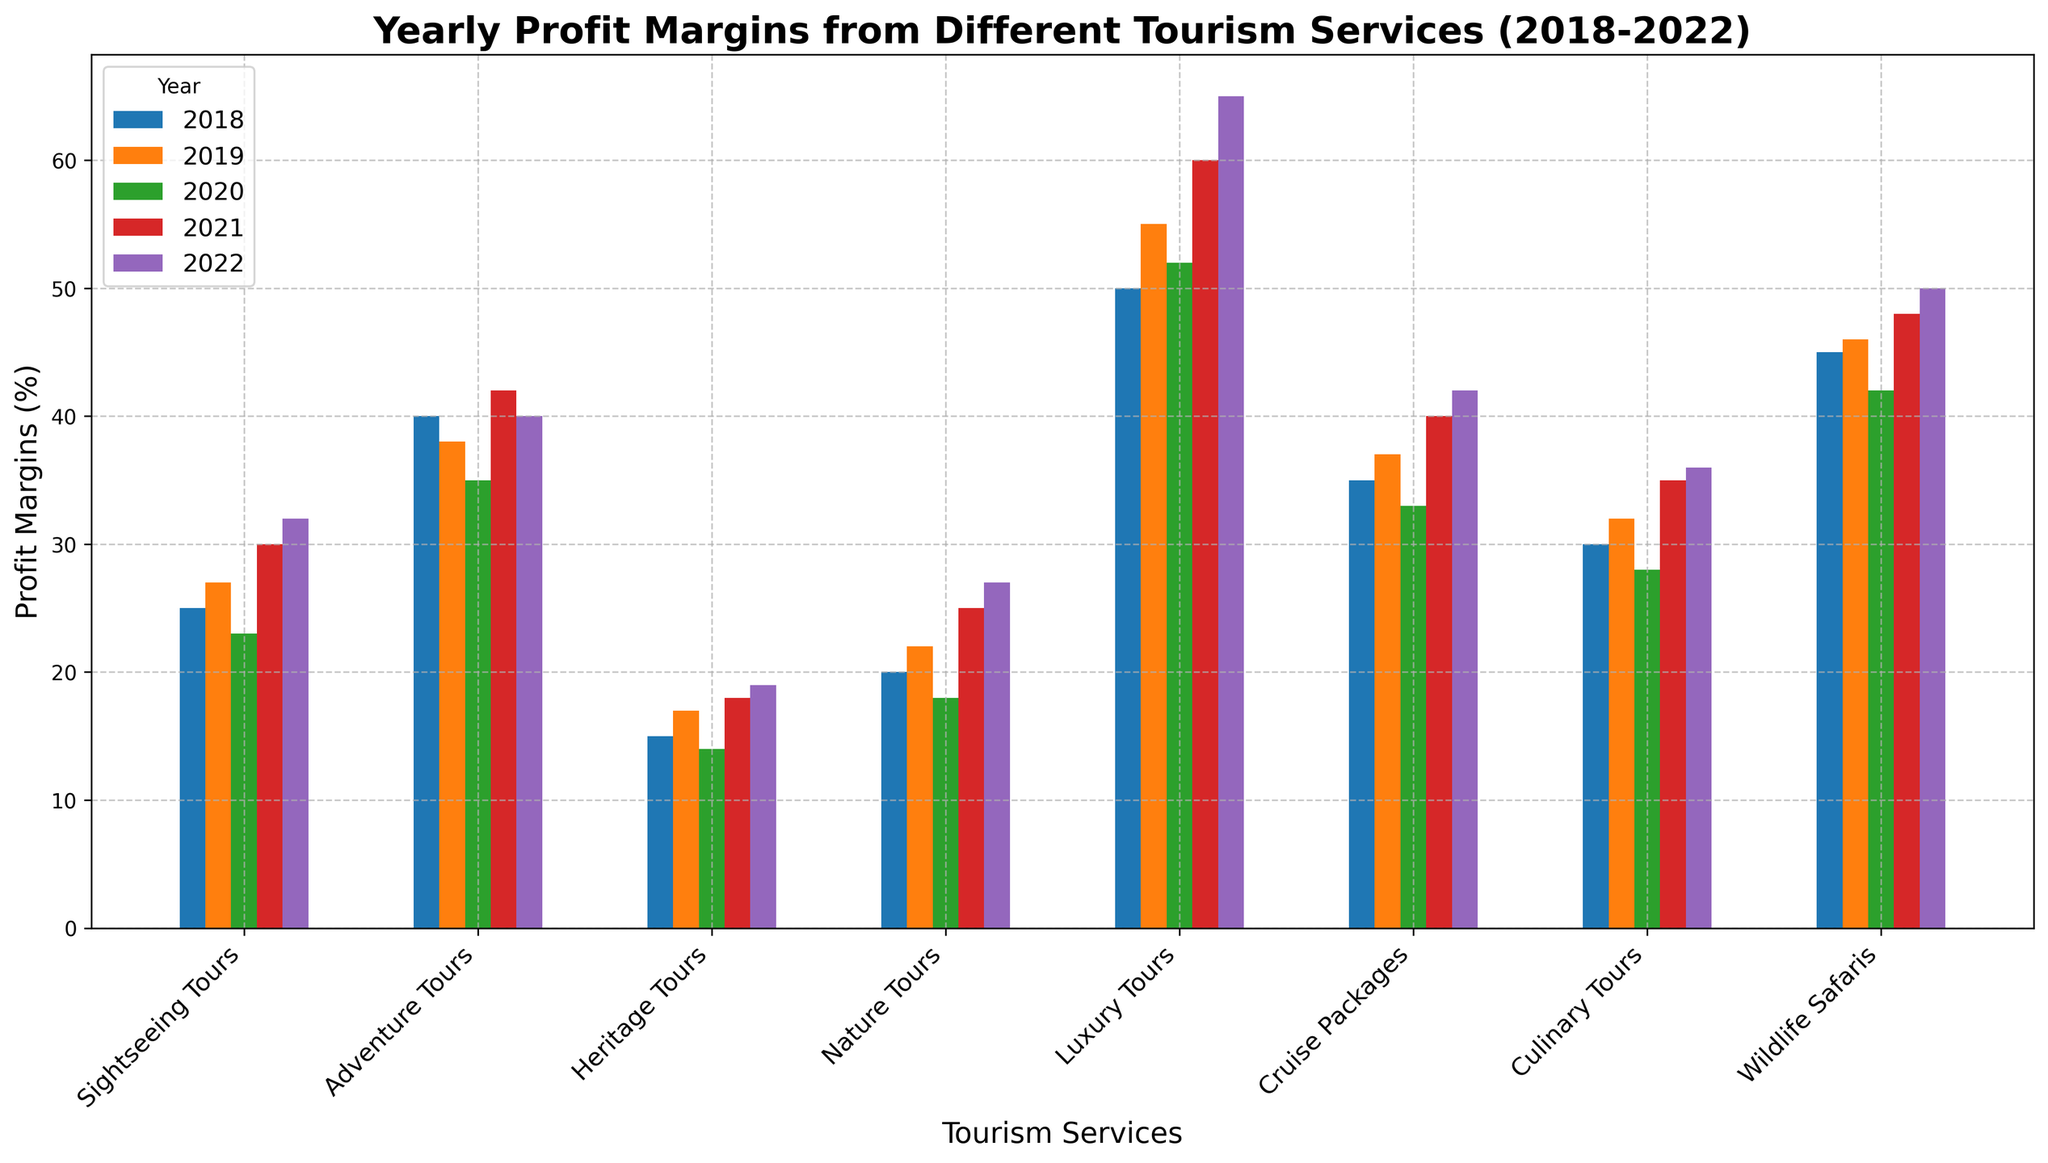Which tourism service had the highest profit margin in 2022? In 2022, examine the heights of the bars for each group. Identify the tallest bar.
Answer: Luxury Tours Which tourism service had the lowest profit margin in 2020? In 2020, look for the shortest bar among the groups. Identify the corresponding service.
Answer: Heritage Tours How did the profit margin of Adventure Tours change from 2019 to 2021? Compare the heights of the bars for Adventure Tours between 2019 and 2021. Calculate the difference (42 - 38).
Answer: Increased by 4% What is the average profit margin for Culinary Tours over the five years? Add the profit margins for Culinary Tours from 2018 to 2022 (30 + 32 + 28 + 35 + 36) and divide by 5.
Answer: 32.2% Which year showed the highest overall profit margin for Nature Tours? Examine the bars for Nature Tours across all years and identify the tallest bar.
Answer: 2022 Compare the profit margins of Cruise Packages in 2020 and Luxury Tours in 2018. Which was higher? Compare the heights of the Cruise Packages bar in 2020 to the Luxury Tours bar in 2018.
Answer: Luxury Tours in 2018 What is the total combined profit margin of Sightseeing Tours and Heritage Tours in 2022? Add the two profit margins (32 for Sightseeing Tours and 19 for Heritage Tours).
Answer: 51% Which tourism service showed the most consistent profit margins over the five years? Identify the service with bars closest in height across all five years.
Answer: Wildlife Safaris By how much did the profit margin of Wildlife Safaris increase from 2018 to 2022? Subtract the profit margin in 2018 from that in 2022 (50 - 45).
Answer: Increased by 5% Did any tourism service have a higher profit margin in 2020 compared to 2018? Compare the heights of the bars from 2020 to those from 2018 for each service. Identify any service where 2020's bar is taller.
Answer: No 